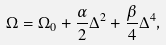<formula> <loc_0><loc_0><loc_500><loc_500>\Omega = \Omega _ { 0 } + \frac { \alpha } { 2 } \Delta ^ { 2 } + \frac { \beta } { 4 } \Delta ^ { 4 } ,</formula> 